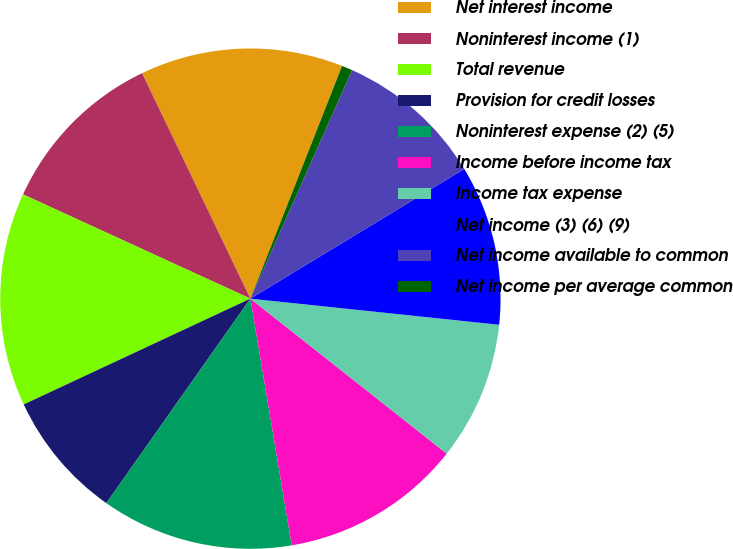Convert chart to OTSL. <chart><loc_0><loc_0><loc_500><loc_500><pie_chart><fcel>Net interest income<fcel>Noninterest income (1)<fcel>Total revenue<fcel>Provision for credit losses<fcel>Noninterest expense (2) (5)<fcel>Income before income tax<fcel>Income tax expense<fcel>Net income (3) (6) (9)<fcel>Net income available to common<fcel>Net income per average common<nl><fcel>13.1%<fcel>11.03%<fcel>13.79%<fcel>8.28%<fcel>12.41%<fcel>11.72%<fcel>8.97%<fcel>10.34%<fcel>9.66%<fcel>0.69%<nl></chart> 